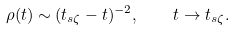Convert formula to latex. <formula><loc_0><loc_0><loc_500><loc_500>\rho ( t ) \sim ( t _ { s \zeta } - t ) ^ { - 2 } , \quad t \rightarrow t _ { s \zeta } .</formula> 